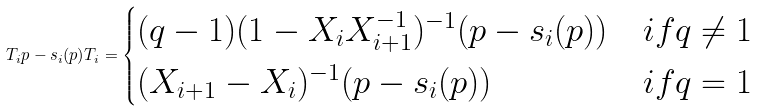Convert formula to latex. <formula><loc_0><loc_0><loc_500><loc_500>T _ { i } p - s _ { i } ( p ) T _ { i } = \begin{cases} ( q - 1 ) ( 1 - X _ { i } X _ { i + 1 } ^ { - 1 } ) ^ { - 1 } ( p - s _ { i } ( p ) ) & i f q \not = 1 \\ ( X _ { i + 1 } - X _ { i } ) ^ { - 1 } ( p - s _ { i } ( p ) ) & i f q = 1 \end{cases}</formula> 